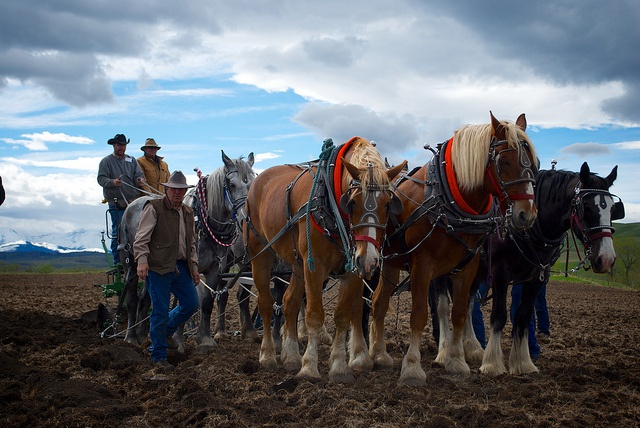Describe the objects in this image and their specific colors. I can see horse in gray, black, and maroon tones, horse in gray, black, and maroon tones, horse in gray and black tones, people in gray, black, maroon, and navy tones, and horse in gray, black, and darkgray tones in this image. 